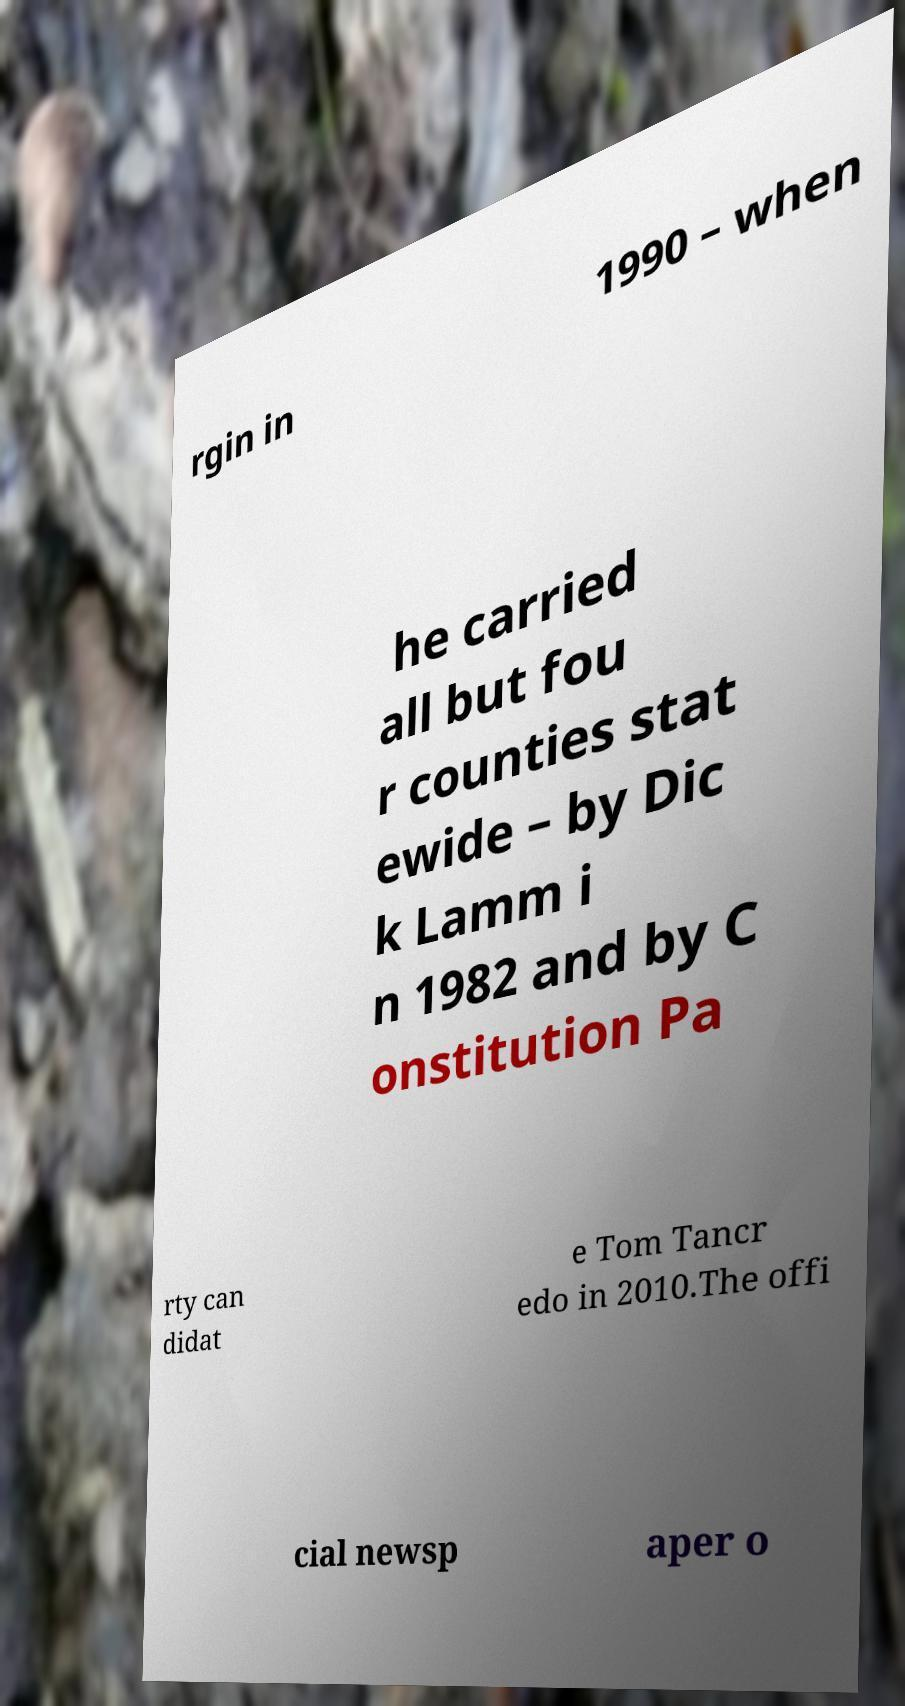I need the written content from this picture converted into text. Can you do that? rgin in 1990 – when he carried all but fou r counties stat ewide – by Dic k Lamm i n 1982 and by C onstitution Pa rty can didat e Tom Tancr edo in 2010.The offi cial newsp aper o 